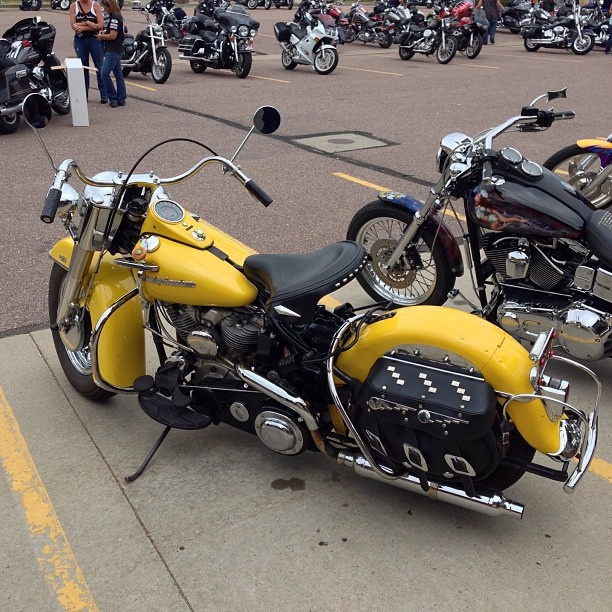Describe the objects in this image and their specific colors. I can see motorcycle in gray, black, darkgray, and gold tones, motorcycle in gray, black, darkgray, and lightgray tones, motorcycle in gray, black, and darkgray tones, motorcycle in gray, black, and darkgray tones, and motorcycle in gray, black, darkgray, and lightgray tones in this image. 